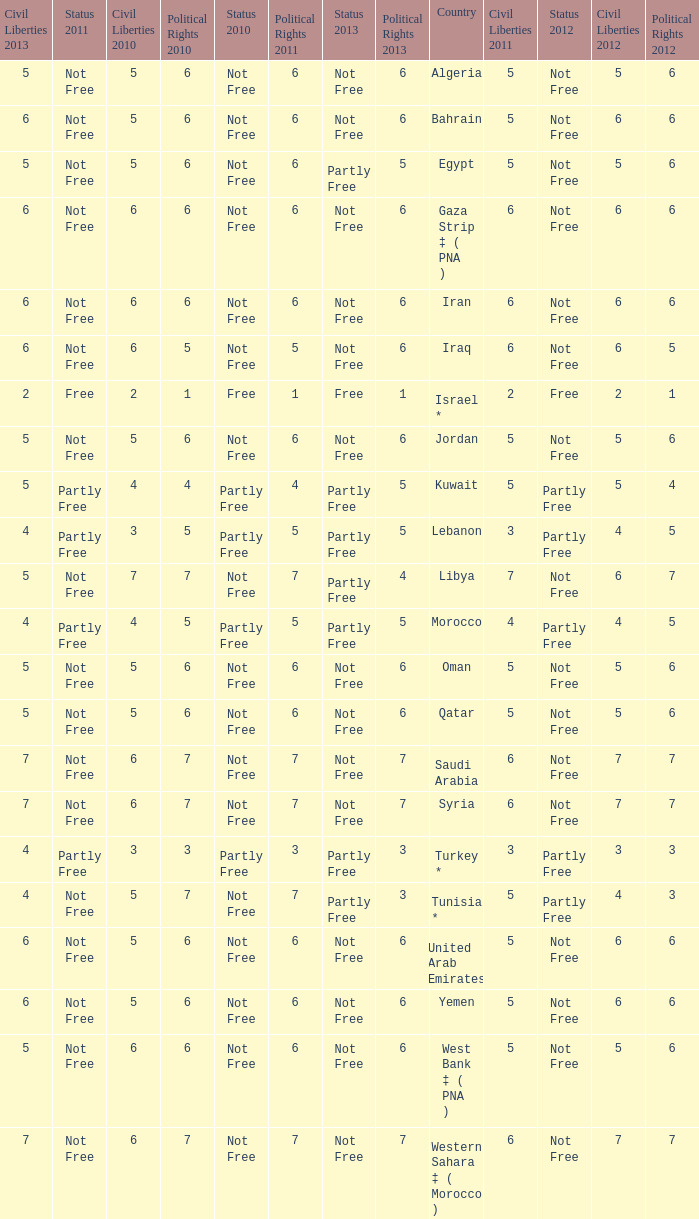How many civil liberties 2013 values are associated with a 2010 political rights value of 6, civil liberties 2012 values over 5, and political rights 2011 under 6? 0.0. Can you parse all the data within this table? {'header': ['Civil Liberties 2013', 'Status 2011', 'Civil Liberties 2010', 'Political Rights 2010', 'Status 2010', 'Political Rights 2011', 'Status 2013', 'Political Rights 2013', 'Country', 'Civil Liberties 2011', 'Status 2012', 'Civil Liberties 2012', 'Political Rights 2012'], 'rows': [['5', 'Not Free', '5', '6', 'Not Free', '6', 'Not Free', '6', 'Algeria', '5', 'Not Free', '5', '6'], ['6', 'Not Free', '5', '6', 'Not Free', '6', 'Not Free', '6', 'Bahrain', '5', 'Not Free', '6', '6'], ['5', 'Not Free', '5', '6', 'Not Free', '6', 'Partly Free', '5', 'Egypt', '5', 'Not Free', '5', '6'], ['6', 'Not Free', '6', '6', 'Not Free', '6', 'Not Free', '6', 'Gaza Strip ‡ ( PNA )', '6', 'Not Free', '6', '6'], ['6', 'Not Free', '6', '6', 'Not Free', '6', 'Not Free', '6', 'Iran', '6', 'Not Free', '6', '6'], ['6', 'Not Free', '6', '5', 'Not Free', '5', 'Not Free', '6', 'Iraq', '6', 'Not Free', '6', '5'], ['2', 'Free', '2', '1', 'Free', '1', 'Free', '1', 'Israel *', '2', 'Free', '2', '1'], ['5', 'Not Free', '5', '6', 'Not Free', '6', 'Not Free', '6', 'Jordan', '5', 'Not Free', '5', '6'], ['5', 'Partly Free', '4', '4', 'Partly Free', '4', 'Partly Free', '5', 'Kuwait', '5', 'Partly Free', '5', '4'], ['4', 'Partly Free', '3', '5', 'Partly Free', '5', 'Partly Free', '5', 'Lebanon', '3', 'Partly Free', '4', '5'], ['5', 'Not Free', '7', '7', 'Not Free', '7', 'Partly Free', '4', 'Libya', '7', 'Not Free', '6', '7'], ['4', 'Partly Free', '4', '5', 'Partly Free', '5', 'Partly Free', '5', 'Morocco', '4', 'Partly Free', '4', '5'], ['5', 'Not Free', '5', '6', 'Not Free', '6', 'Not Free', '6', 'Oman', '5', 'Not Free', '5', '6'], ['5', 'Not Free', '5', '6', 'Not Free', '6', 'Not Free', '6', 'Qatar', '5', 'Not Free', '5', '6'], ['7', 'Not Free', '6', '7', 'Not Free', '7', 'Not Free', '7', 'Saudi Arabia', '6', 'Not Free', '7', '7'], ['7', 'Not Free', '6', '7', 'Not Free', '7', 'Not Free', '7', 'Syria', '6', 'Not Free', '7', '7'], ['4', 'Partly Free', '3', '3', 'Partly Free', '3', 'Partly Free', '3', 'Turkey *', '3', 'Partly Free', '3', '3'], ['4', 'Not Free', '5', '7', 'Not Free', '7', 'Partly Free', '3', 'Tunisia *', '5', 'Partly Free', '4', '3'], ['6', 'Not Free', '5', '6', 'Not Free', '6', 'Not Free', '6', 'United Arab Emirates', '5', 'Not Free', '6', '6'], ['6', 'Not Free', '5', '6', 'Not Free', '6', 'Not Free', '6', 'Yemen', '5', 'Not Free', '6', '6'], ['5', 'Not Free', '6', '6', 'Not Free', '6', 'Not Free', '6', 'West Bank ‡ ( PNA )', '5', 'Not Free', '5', '6'], ['7', 'Not Free', '6', '7', 'Not Free', '7', 'Not Free', '7', 'Western Sahara ‡ ( Morocco )', '6', 'Not Free', '7', '7']]} 